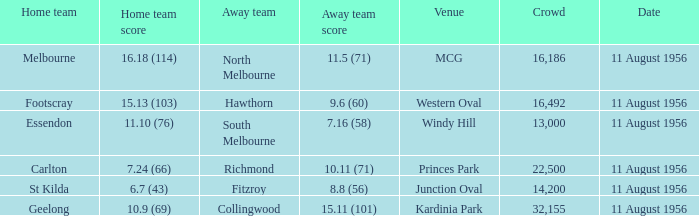Where did a home team score 10.9 (69)? Kardinia Park. 